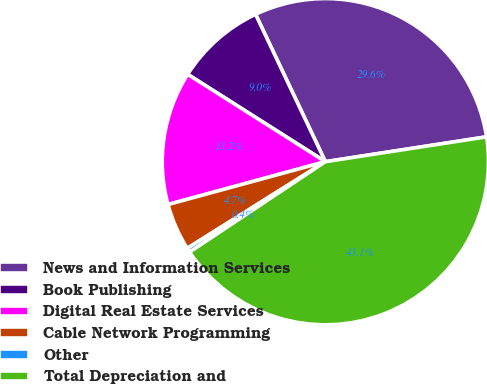Convert chart to OTSL. <chart><loc_0><loc_0><loc_500><loc_500><pie_chart><fcel>News and Information Services<fcel>Book Publishing<fcel>Digital Real Estate Services<fcel>Cable Network Programming<fcel>Other<fcel>Total Depreciation and<nl><fcel>29.61%<fcel>8.96%<fcel>13.23%<fcel>4.69%<fcel>0.43%<fcel>43.09%<nl></chart> 